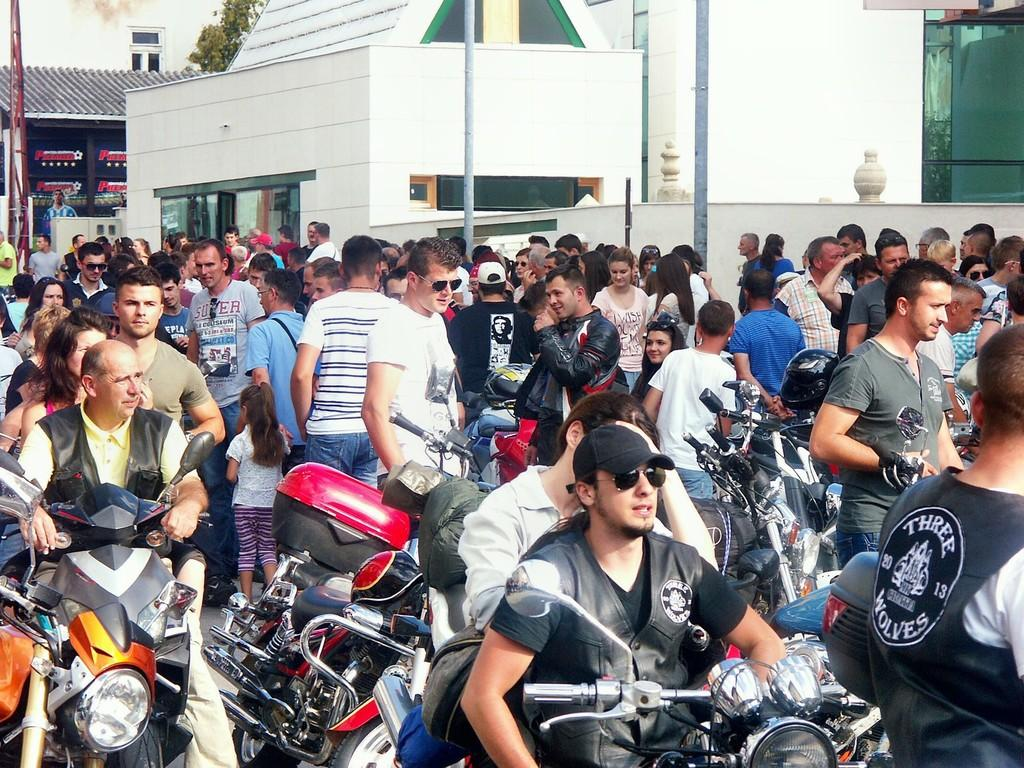How many people are present in the image? There are many people in the image. What are some of the people doing in the image? Some people are sitting on vehicles, while others are standing. What can be seen in the background of the image? There are buildings and a tree in the background of the image. What type of veil is being worn by the people in the image? There is no mention of veils being worn by the people in the image. --- Facts: 1. There is a person in the image. 2. The person is wearing a hat. 3. The person is holding a book. 4. The person is sitting on a bench. 5. There is a body of water in the background of the image. Absurd Topics: elephant, piano Conversation: Who or what is present in the image? There is a person in the image. What is the person wearing? The person is wearing a hat. What is the person holding? The person is holding a book. What is the person doing? The person is sitting on a bench. What can be seen in the background of the image? There is a body of water in the background of the image. Reasoning: Let's think step by step in order to produce the conversation. We start by identifying the main subject of the image, which is the person. Then, we describe specific details about the person, such as the hat they are wearing and the book they are holding. Next, we mention the person's action, which is sitting on a bench. Finally, we describe the background, which includes a body of water. Absurd Question/Answer: What type of elephant can be seen playing the piano in the image? There is no mention of an elephant or a piano in the image. 